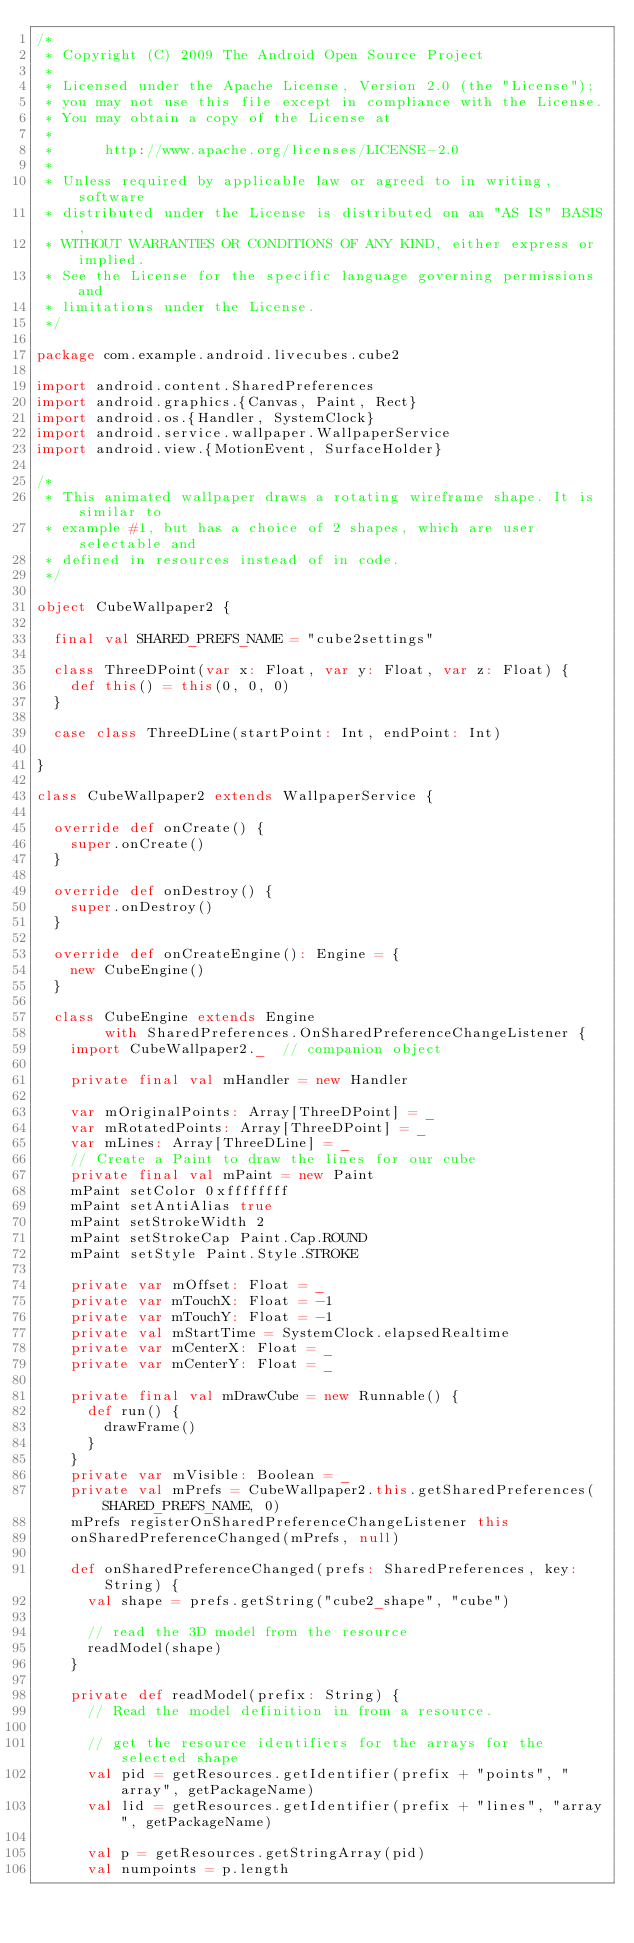<code> <loc_0><loc_0><loc_500><loc_500><_Scala_>/*
 * Copyright (C) 2009 The Android Open Source Project
 *
 * Licensed under the Apache License, Version 2.0 (the "License");
 * you may not use this file except in compliance with the License.
 * You may obtain a copy of the License at
 *
 *      http://www.apache.org/licenses/LICENSE-2.0
 *
 * Unless required by applicable law or agreed to in writing, software
 * distributed under the License is distributed on an "AS IS" BASIS,
 * WITHOUT WARRANTIES OR CONDITIONS OF ANY KIND, either express or implied.
 * See the License for the specific language governing permissions and
 * limitations under the License.
 */

package com.example.android.livecubes.cube2

import android.content.SharedPreferences
import android.graphics.{Canvas, Paint, Rect}
import android.os.{Handler, SystemClock}
import android.service.wallpaper.WallpaperService
import android.view.{MotionEvent, SurfaceHolder}

/*
 * This animated wallpaper draws a rotating wireframe shape. It is similar to
 * example #1, but has a choice of 2 shapes, which are user selectable and
 * defined in resources instead of in code.
 */

object CubeWallpaper2 {

  final val SHARED_PREFS_NAME = "cube2settings"

  class ThreeDPoint(var x: Float, var y: Float, var z: Float) {
    def this() = this(0, 0, 0)
  }

  case class ThreeDLine(startPoint: Int, endPoint: Int)

}

class CubeWallpaper2 extends WallpaperService {

  override def onCreate() {
    super.onCreate()
  }

  override def onDestroy() {
    super.onDestroy()
  }

  override def onCreateEngine(): Engine = {
    new CubeEngine()
  }

  class CubeEngine extends Engine 
        with SharedPreferences.OnSharedPreferenceChangeListener {
    import CubeWallpaper2._  // companion object

    private final val mHandler = new Handler

    var mOriginalPoints: Array[ThreeDPoint] = _
    var mRotatedPoints: Array[ThreeDPoint] = _
    var mLines: Array[ThreeDLine] = _
    // Create a Paint to draw the lines for our cube
    private final val mPaint = new Paint
    mPaint setColor 0xffffffff
    mPaint setAntiAlias true
    mPaint setStrokeWidth 2
    mPaint setStrokeCap Paint.Cap.ROUND
    mPaint setStyle Paint.Style.STROKE

    private var mOffset: Float = _
    private var mTouchX: Float = -1
    private var mTouchY: Float = -1
    private val mStartTime = SystemClock.elapsedRealtime
    private var mCenterX: Float = _
    private var mCenterY: Float = _

    private final val mDrawCube = new Runnable() {
      def run() {
        drawFrame()
      }
    }
    private var mVisible: Boolean = _
    private val mPrefs = CubeWallpaper2.this.getSharedPreferences(SHARED_PREFS_NAME, 0)
    mPrefs registerOnSharedPreferenceChangeListener this
    onSharedPreferenceChanged(mPrefs, null)

    def onSharedPreferenceChanged(prefs: SharedPreferences, key: String) {
      val shape = prefs.getString("cube2_shape", "cube")

      // read the 3D model from the resource
      readModel(shape)
    }

    private def readModel(prefix: String) {
      // Read the model definition in from a resource.

      // get the resource identifiers for the arrays for the selected shape
      val pid = getResources.getIdentifier(prefix + "points", "array", getPackageName)
      val lid = getResources.getIdentifier(prefix + "lines", "array", getPackageName)

      val p = getResources.getStringArray(pid)
      val numpoints = p.length</code> 